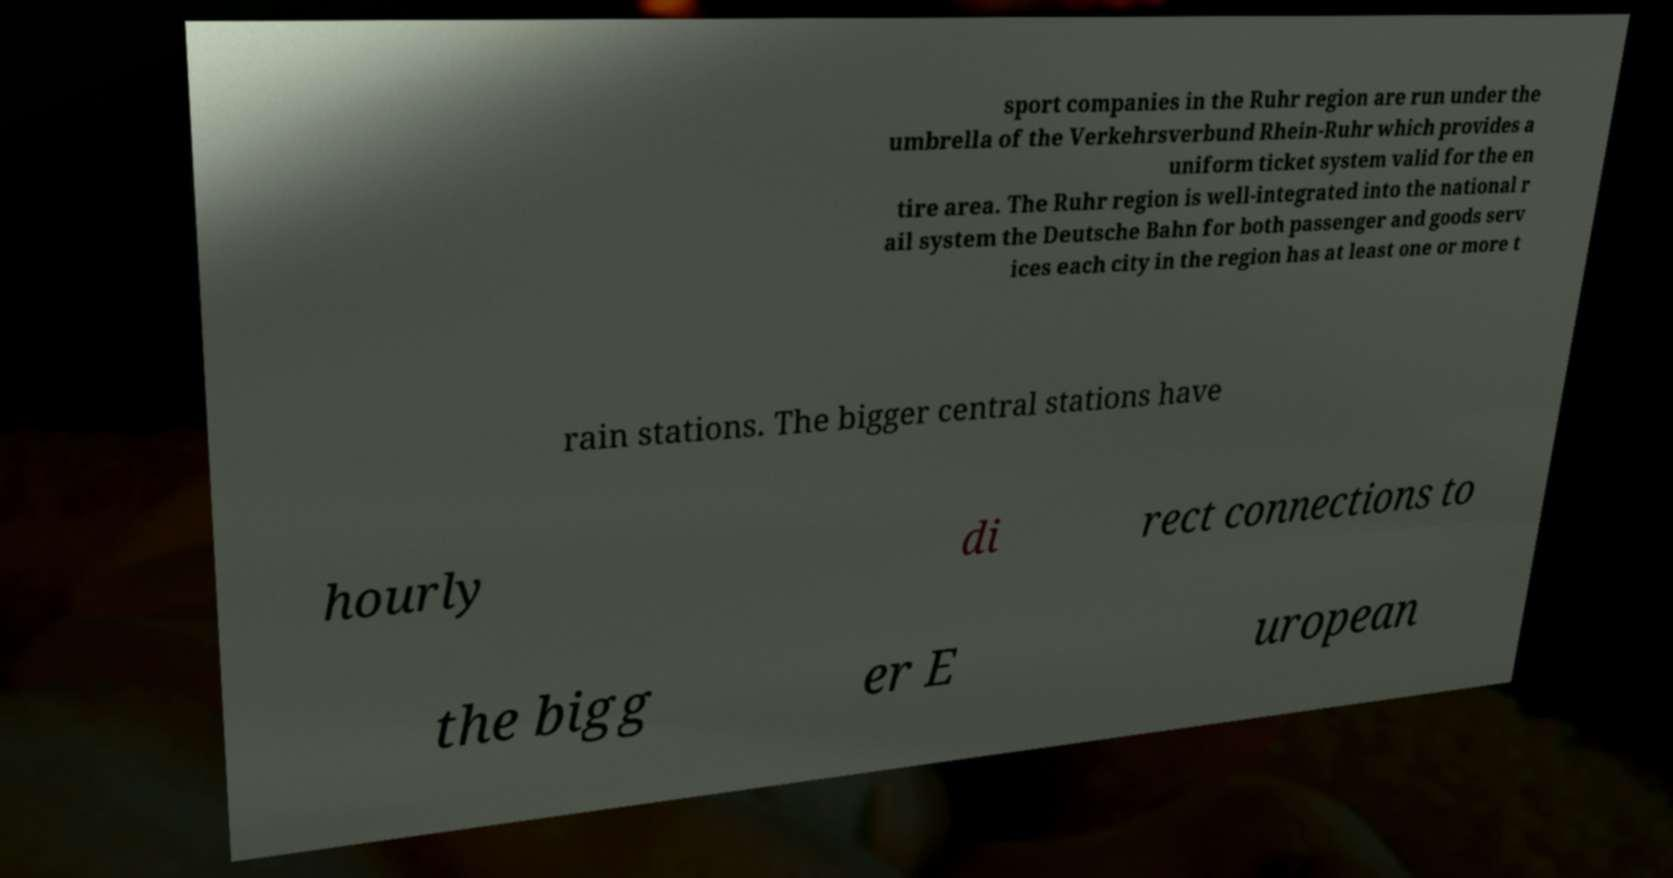Please identify and transcribe the text found in this image. sport companies in the Ruhr region are run under the umbrella of the Verkehrsverbund Rhein-Ruhr which provides a uniform ticket system valid for the en tire area. The Ruhr region is well-integrated into the national r ail system the Deutsche Bahn for both passenger and goods serv ices each city in the region has at least one or more t rain stations. The bigger central stations have hourly di rect connections to the bigg er E uropean 